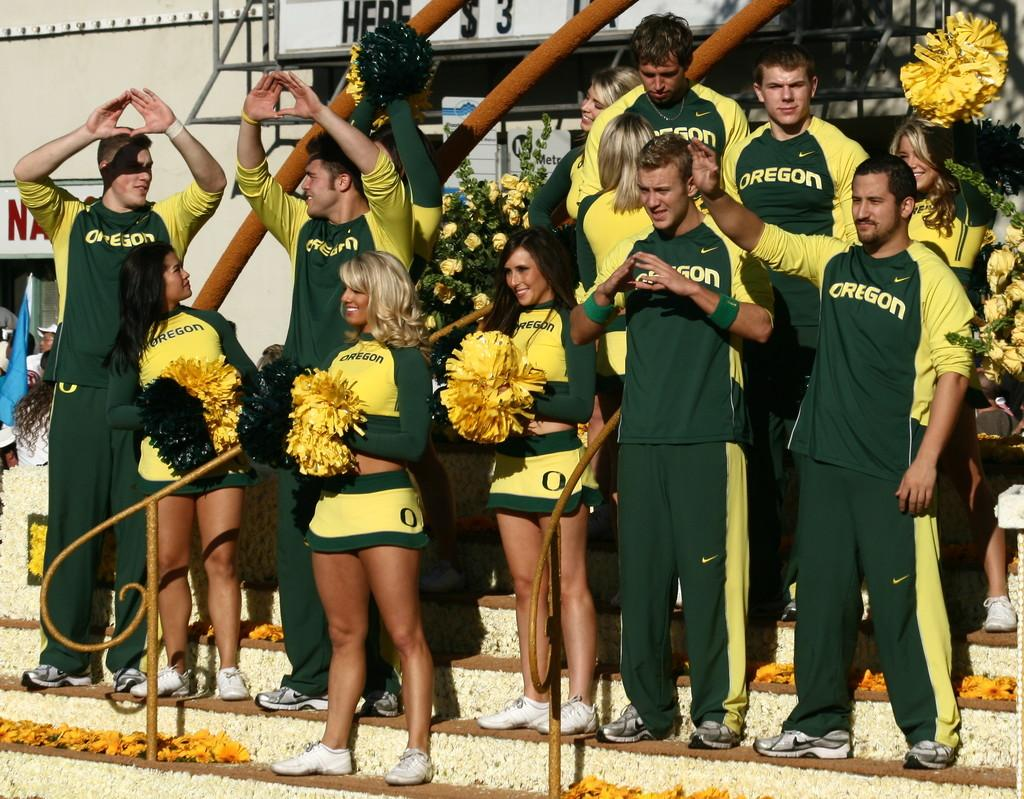Provide a one-sentence caption for the provided image. Oregon cheerleaders stand on bleachers cheering for their team. 